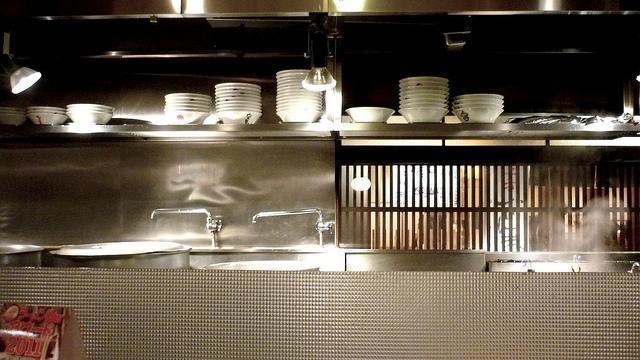How many sinks are there?
Give a very brief answer. 2. How many people are entering the train?
Give a very brief answer. 0. 